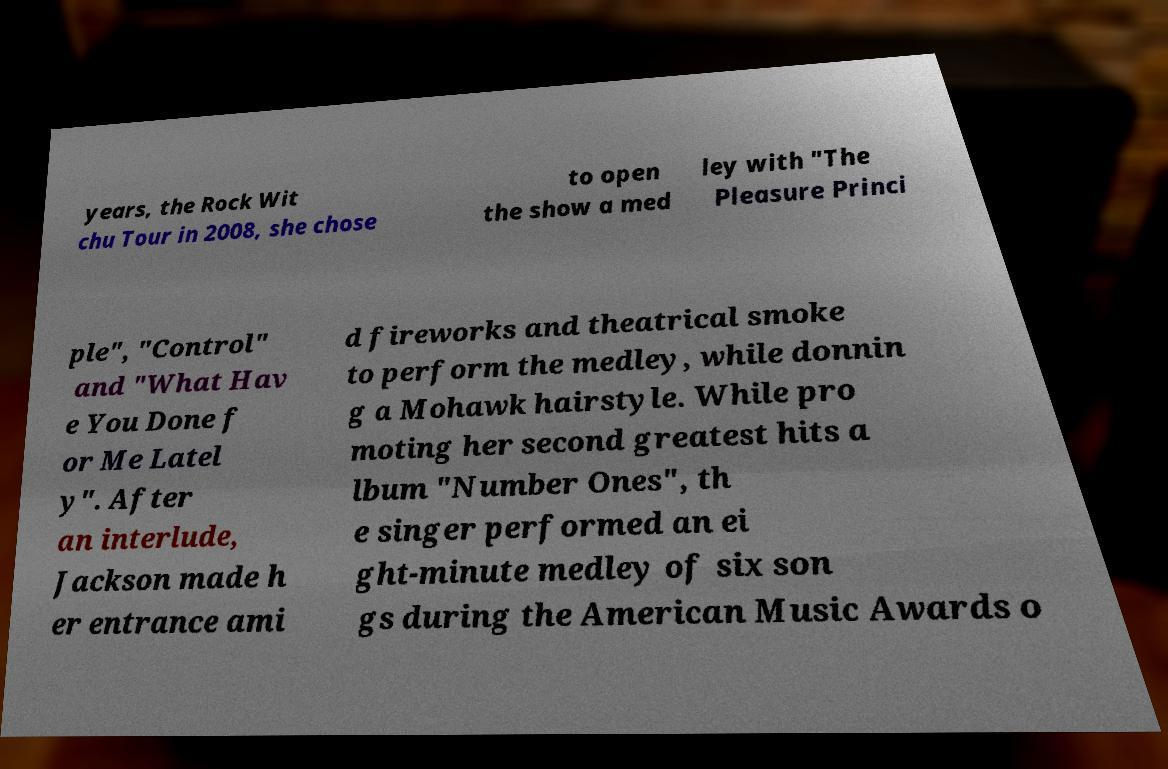For documentation purposes, I need the text within this image transcribed. Could you provide that? years, the Rock Wit chu Tour in 2008, she chose to open the show a med ley with "The Pleasure Princi ple", "Control" and "What Hav e You Done f or Me Latel y". After an interlude, Jackson made h er entrance ami d fireworks and theatrical smoke to perform the medley, while donnin g a Mohawk hairstyle. While pro moting her second greatest hits a lbum "Number Ones", th e singer performed an ei ght-minute medley of six son gs during the American Music Awards o 